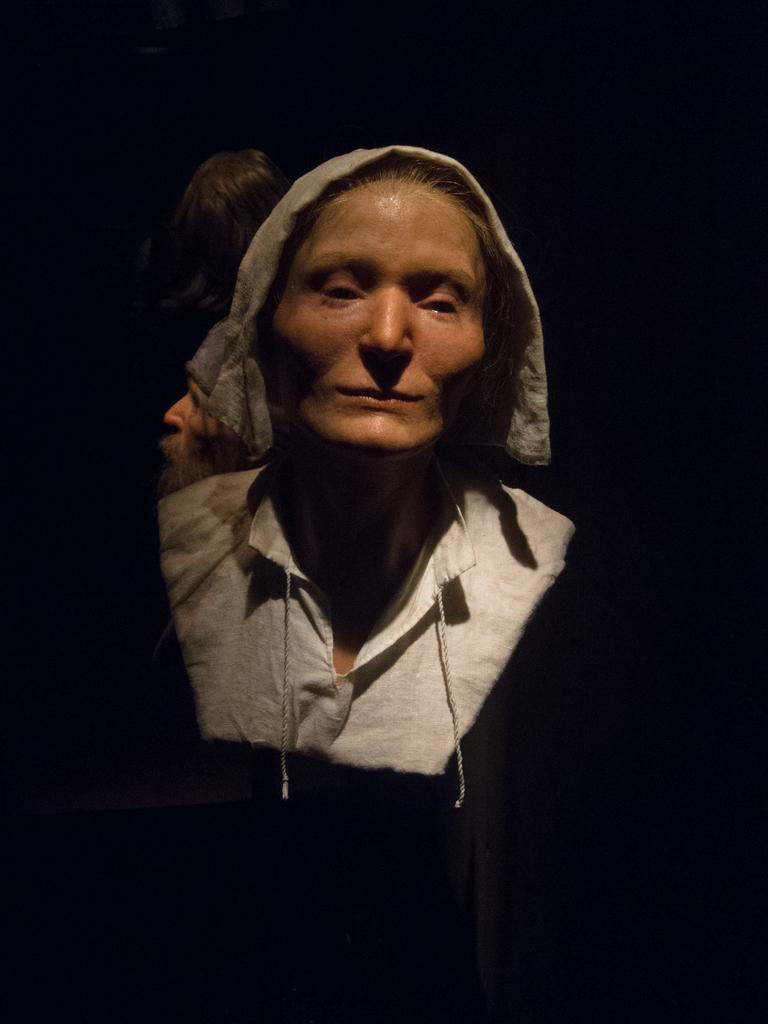What is the overall tone or lighting of the image? The picture is dark. Can you identify any human presence in the image? Yes, there is a person in the image. What physical feature of the person can be seen in the image? Hair is visible in the image. What type of range can be seen in the image? There is no range present in the image. How many pickles are visible in the image? There are no pickles present in the image. 